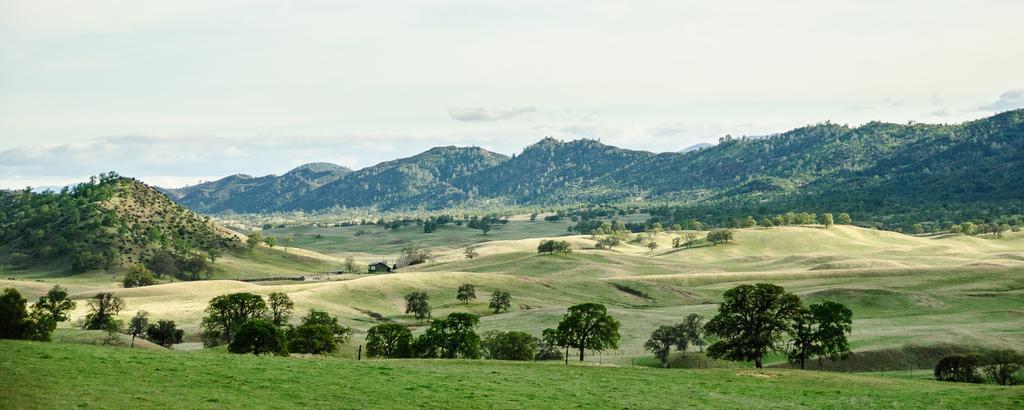Describe this image in one or two sentences. In this image I can see some grass, few trees and few mountains. In the background I can see the sky. 